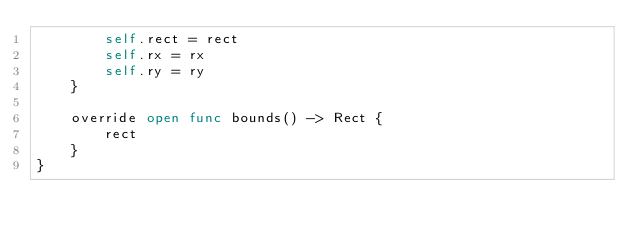Convert code to text. <code><loc_0><loc_0><loc_500><loc_500><_Swift_>        self.rect = rect
        self.rx = rx
        self.ry = ry
    }

    override open func bounds() -> Rect {
        rect
    }
}
</code> 